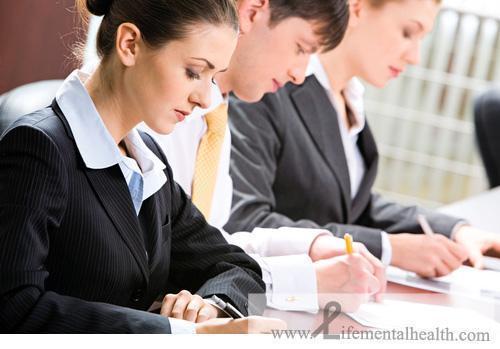How many people are there?
Give a very brief answer. 3. 